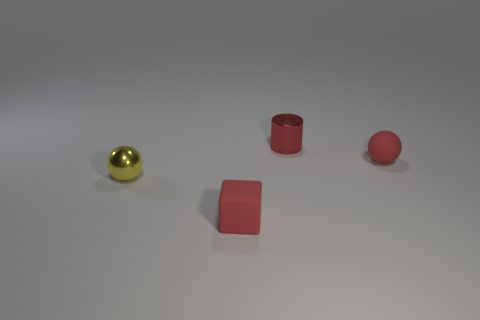Add 3 red metal things. How many objects exist? 7 Subtract all cylinders. How many objects are left? 3 Add 3 tiny yellow shiny spheres. How many tiny yellow shiny spheres are left? 4 Add 2 small red things. How many small red things exist? 5 Subtract 0 gray blocks. How many objects are left? 4 Subtract all metal cylinders. Subtract all red matte spheres. How many objects are left? 2 